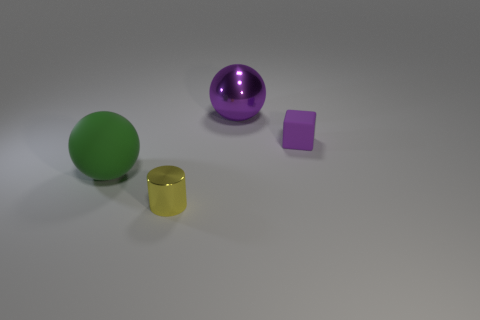Add 3 small yellow metal cylinders. How many objects exist? 7 Subtract all cubes. How many objects are left? 3 Add 1 purple rubber cubes. How many purple rubber cubes are left? 2 Add 4 small brown cylinders. How many small brown cylinders exist? 4 Subtract 0 gray cylinders. How many objects are left? 4 Subtract all red matte spheres. Subtract all big matte objects. How many objects are left? 3 